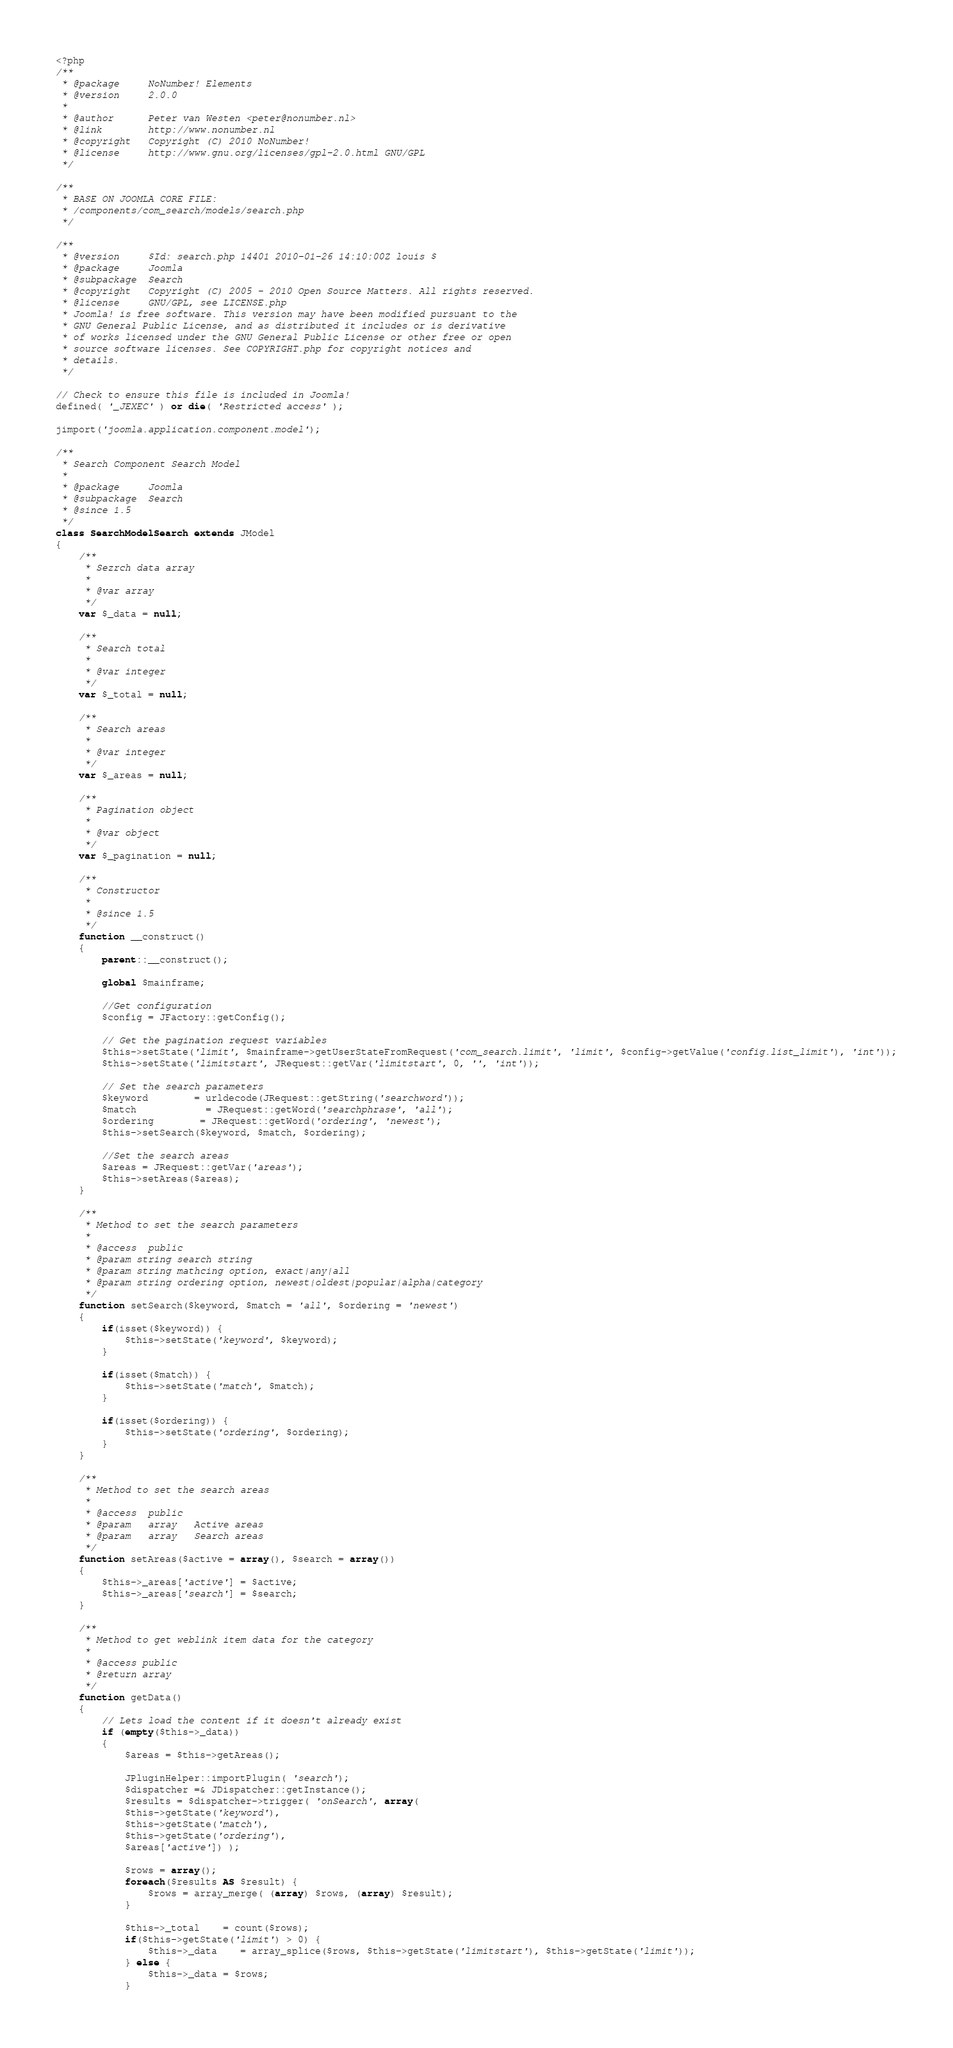Convert code to text. <code><loc_0><loc_0><loc_500><loc_500><_PHP_><?php
/**
 * @package     NoNumber! Elements
 * @version     2.0.0
 *
 * @author      Peter van Westen <peter@nonumber.nl>
 * @link        http://www.nonumber.nl
 * @copyright   Copyright (C) 2010 NoNumber!
 * @license     http://www.gnu.org/licenses/gpl-2.0.html GNU/GPL
 */

/**
 * BASE ON JOOMLA CORE FILE:
 * /components/com_search/models/search.php
 */

/**
 * @version		$Id: search.php 14401 2010-01-26 14:10:00Z louis $
 * @package		Joomla
 * @subpackage	Search
 * @copyright	Copyright (C) 2005 - 2010 Open Source Matters. All rights reserved.
 * @license		GNU/GPL, see LICENSE.php
 * Joomla! is free software. This version may have been modified pursuant to the
 * GNU General Public License, and as distributed it includes or is derivative
 * of works licensed under the GNU General Public License or other free or open
 * source software licenses. See COPYRIGHT.php for copyright notices and
 * details.
 */

// Check to ensure this file is included in Joomla!
defined( '_JEXEC' ) or die( 'Restricted access' );

jimport('joomla.application.component.model');

/**
 * Search Component Search Model
 *
 * @package		Joomla
 * @subpackage	Search
 * @since 1.5
 */
class SearchModelSearch extends JModel
{
	/**
	 * Sezrch data array
	 *
	 * @var array
	 */
	var $_data = null;

	/**
	 * Search total
	 *
	 * @var integer
	 */
	var $_total = null;

	/**
	 * Search areas
	 *
	 * @var integer
	 */
	var $_areas = null;

	/**
	 * Pagination object
	 *
	 * @var object
	 */
	var $_pagination = null;

	/**
	 * Constructor
	 *
	 * @since 1.5
	 */
	function __construct()
	{
		parent::__construct();

		global $mainframe;

		//Get configuration
		$config = JFactory::getConfig();

		// Get the pagination request variables
		$this->setState('limit', $mainframe->getUserStateFromRequest('com_search.limit', 'limit', $config->getValue('config.list_limit'), 'int'));
		$this->setState('limitstart', JRequest::getVar('limitstart', 0, '', 'int'));

		// Set the search parameters
		$keyword		= urldecode(JRequest::getString('searchword'));
		$match			= JRequest::getWord('searchphrase', 'all');
		$ordering		= JRequest::getWord('ordering', 'newest');
		$this->setSearch($keyword, $match, $ordering);

		//Set the search areas
		$areas = JRequest::getVar('areas');
		$this->setAreas($areas);
	}

	/**
	 * Method to set the search parameters
	 *
	 * @access	public
	 * @param string search string
 	 * @param string mathcing option, exact|any|all
 	 * @param string ordering option, newest|oldest|popular|alpha|category
	 */
	function setSearch($keyword, $match = 'all', $ordering = 'newest')
	{
		if(isset($keyword)) {
			$this->setState('keyword', $keyword);
		}

		if(isset($match)) {
			$this->setState('match', $match);
		}

		if(isset($ordering)) {
			$this->setState('ordering', $ordering);
		}
	}

	/**
	 * Method to set the search areas
	 *
	 * @access	public
	 * @param	array	Active areas
	 * @param	array	Search areas
	 */
	function setAreas($active = array(), $search = array())
	{
		$this->_areas['active'] = $active;
		$this->_areas['search'] = $search;
	}

	/**
	 * Method to get weblink item data for the category
	 *
	 * @access public
	 * @return array
	 */
	function getData()
	{
		// Lets load the content if it doesn't already exist
		if (empty($this->_data))
		{
			$areas = $this->getAreas();

			JPluginHelper::importPlugin( 'search');
			$dispatcher =& JDispatcher::getInstance();
			$results = $dispatcher->trigger( 'onSearch', array(
			$this->getState('keyword'),
			$this->getState('match'),
			$this->getState('ordering'),
			$areas['active']) );

			$rows = array();
			foreach($results AS $result) {
				$rows = array_merge( (array) $rows, (array) $result);
			}

			$this->_total	= count($rows);
			if($this->getState('limit') > 0) {
				$this->_data    = array_splice($rows, $this->getState('limitstart'), $this->getState('limit'));
			} else {
				$this->_data = $rows;
			}
</code> 